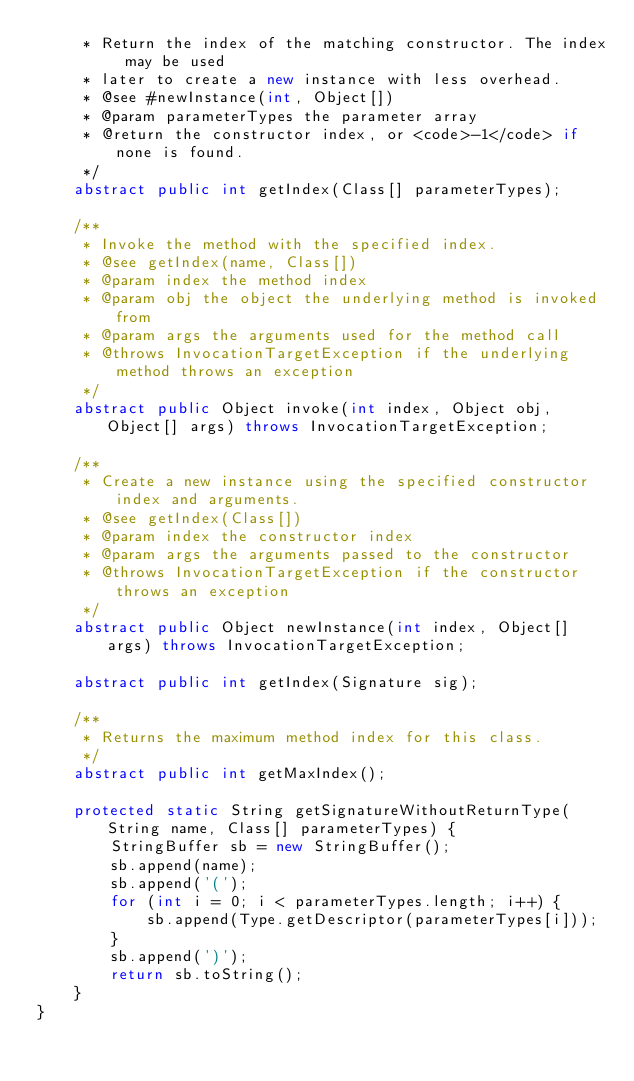Convert code to text. <code><loc_0><loc_0><loc_500><loc_500><_Java_>     * Return the index of the matching constructor. The index may be used
     * later to create a new instance with less overhead.
     * @see #newInstance(int, Object[])
     * @param parameterTypes the parameter array
     * @return the constructor index, or <code>-1</code> if none is found.
     */
    abstract public int getIndex(Class[] parameterTypes);

    /**
     * Invoke the method with the specified index.
     * @see getIndex(name, Class[])
     * @param index the method index
     * @param obj the object the underlying method is invoked from
     * @param args the arguments used for the method call
     * @throws InvocationTargetException if the underlying method throws an exception
     */
    abstract public Object invoke(int index, Object obj, Object[] args) throws InvocationTargetException;

    /**
     * Create a new instance using the specified constructor index and arguments.
     * @see getIndex(Class[])
     * @param index the constructor index
     * @param args the arguments passed to the constructor
     * @throws InvocationTargetException if the constructor throws an exception
     */
    abstract public Object newInstance(int index, Object[] args) throws InvocationTargetException;

    abstract public int getIndex(Signature sig);

    /**
     * Returns the maximum method index for this class.
     */
    abstract public int getMaxIndex();

    protected static String getSignatureWithoutReturnType(String name, Class[] parameterTypes) {
        StringBuffer sb = new StringBuffer();
        sb.append(name);
        sb.append('(');
        for (int i = 0; i < parameterTypes.length; i++) {
            sb.append(Type.getDescriptor(parameterTypes[i]));
        }
        sb.append(')');
        return sb.toString();
    }
}
</code> 